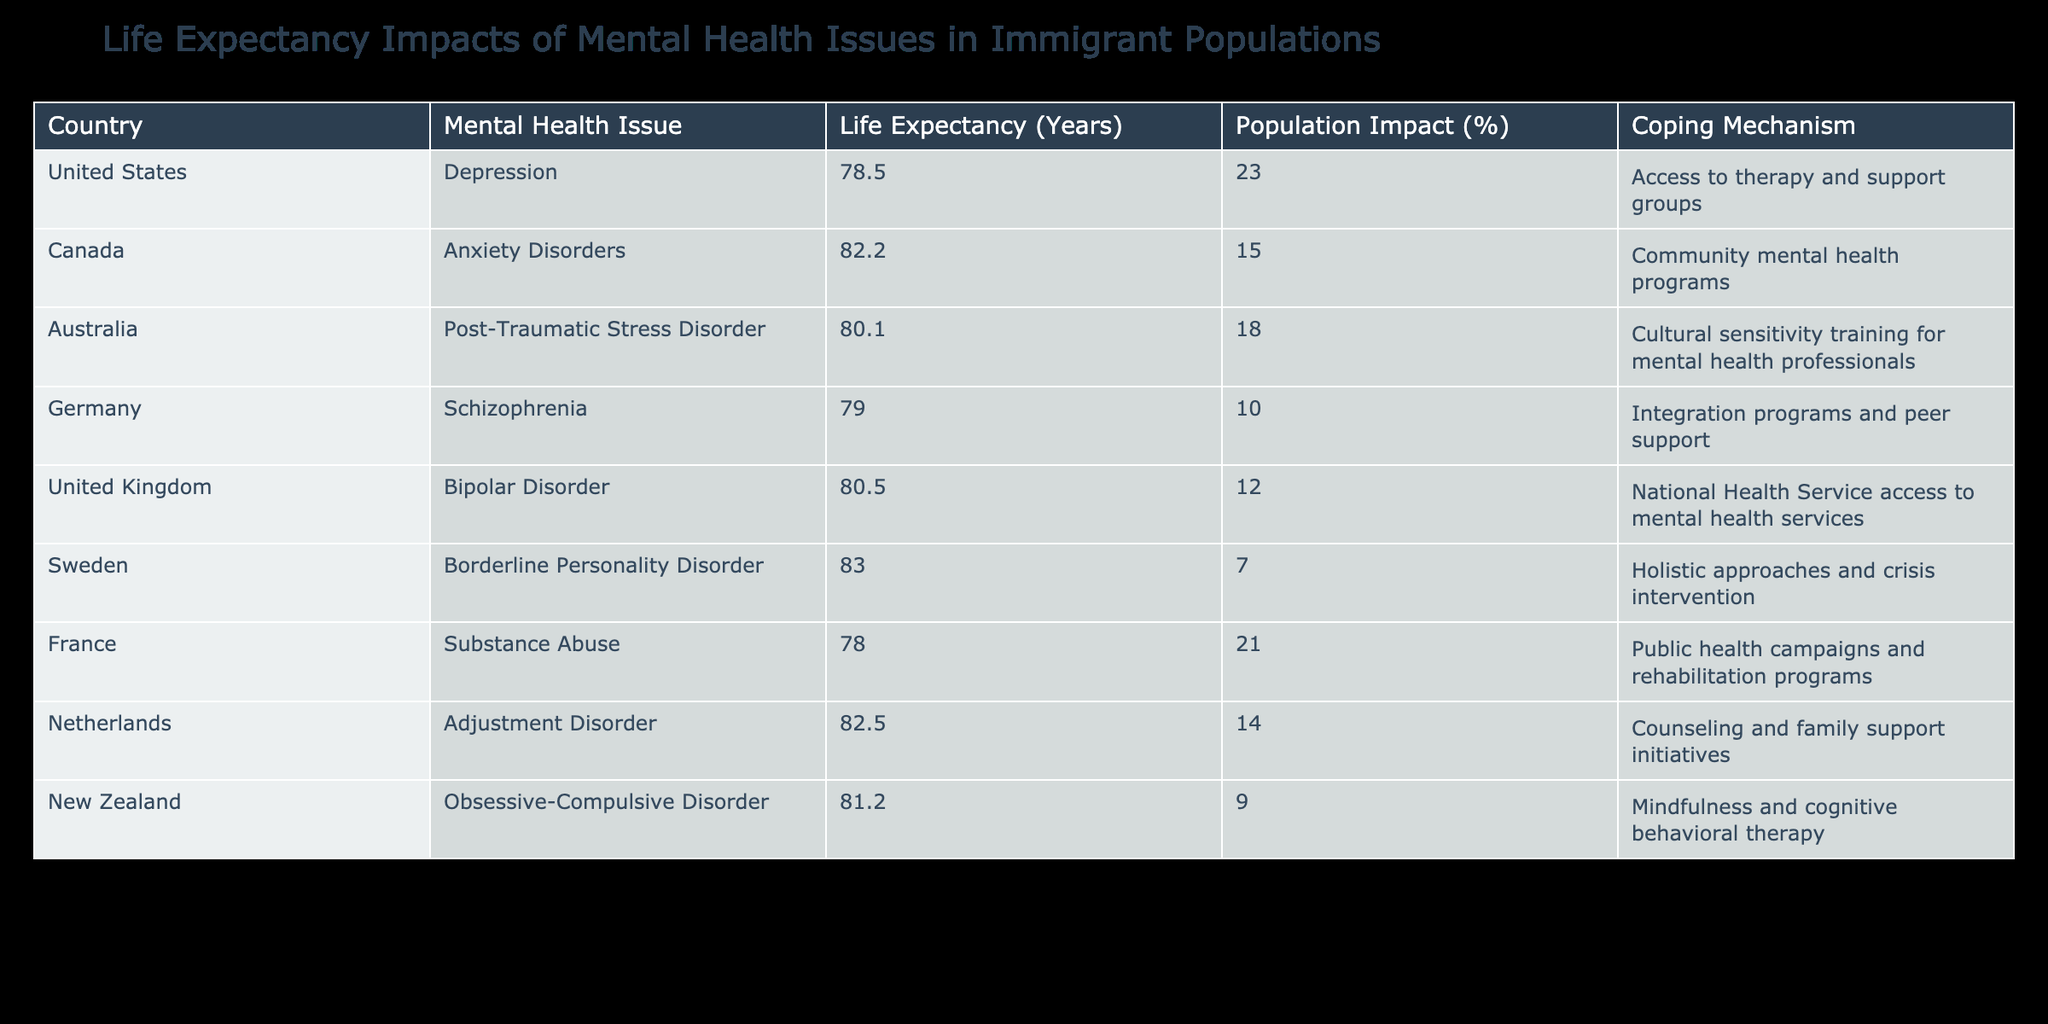What is the life expectancy for individuals with depression in the United States? The table shows that the life expectancy for individuals with depression in the United States is listed as 78.5 years.
Answer: 78.5 Which country has the highest life expectancy for treatment of bipolar disorder? According to the table, the United Kingdom has a life expectancy of 80.5 years for individuals dealing with bipolar disorder, which is the highest among the listed countries for this condition.
Answer: United Kingdom, 80.5 What is the average life expectancy of countries dealing with anxiety disorders and schizophrenia? From the table, Canada has a life expectancy of 82.2 years for anxiety disorders, and Germany has 79.0 years for schizophrenia. The average is calculated as (82.2 + 79.0) / 2 = 80.6 years.
Answer: 80.6 Is Sweden's approach to borderline personality disorder notably different in terms of life expectancy compared to France's approach to substance abuse? Sweden's life expectancy for borderline personality disorder is 83.0 years, while France's for substance abuse is 78.0 years. Therefore, Sweden's approach leads to a notably higher life expectancy.
Answer: Yes How does the life expectancy for individuals with obsessive-compulsive disorder in New Zealand compare to that of those with post-traumatic stress disorder in Australia? In New Zealand, individuals with obsessive-compulsive disorder have a life expectancy of 81.2 years, while in Australia, those with post-traumatic stress disorder have a life expectancy of 80.1 years. New Zealand's life expectancy is higher by 1.1 years.
Answer: New Zealand is 1.1 years higher 